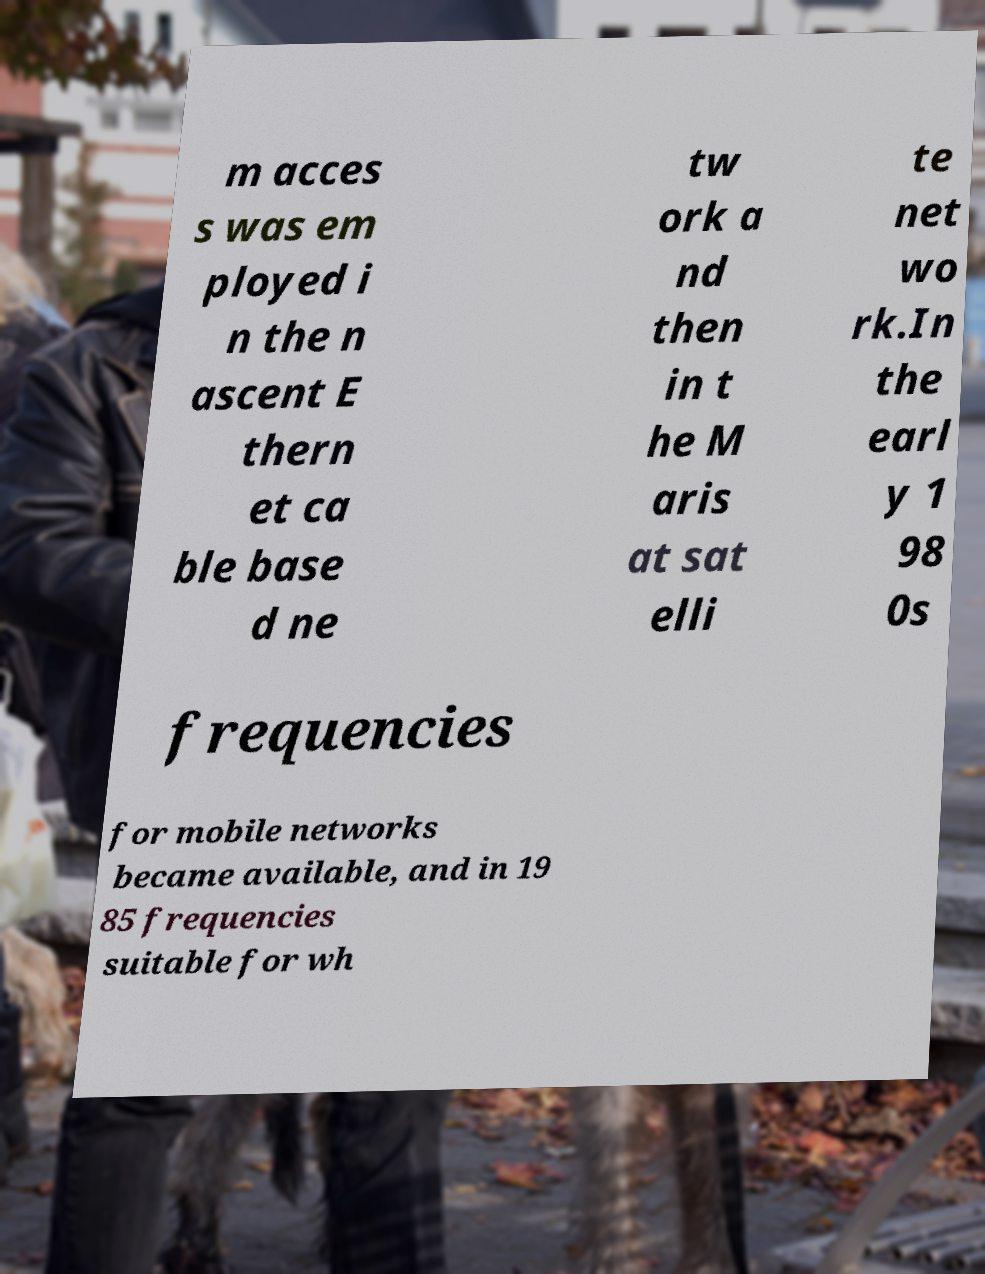Can you read and provide the text displayed in the image?This photo seems to have some interesting text. Can you extract and type it out for me? m acces s was em ployed i n the n ascent E thern et ca ble base d ne tw ork a nd then in t he M aris at sat elli te net wo rk.In the earl y 1 98 0s frequencies for mobile networks became available, and in 19 85 frequencies suitable for wh 